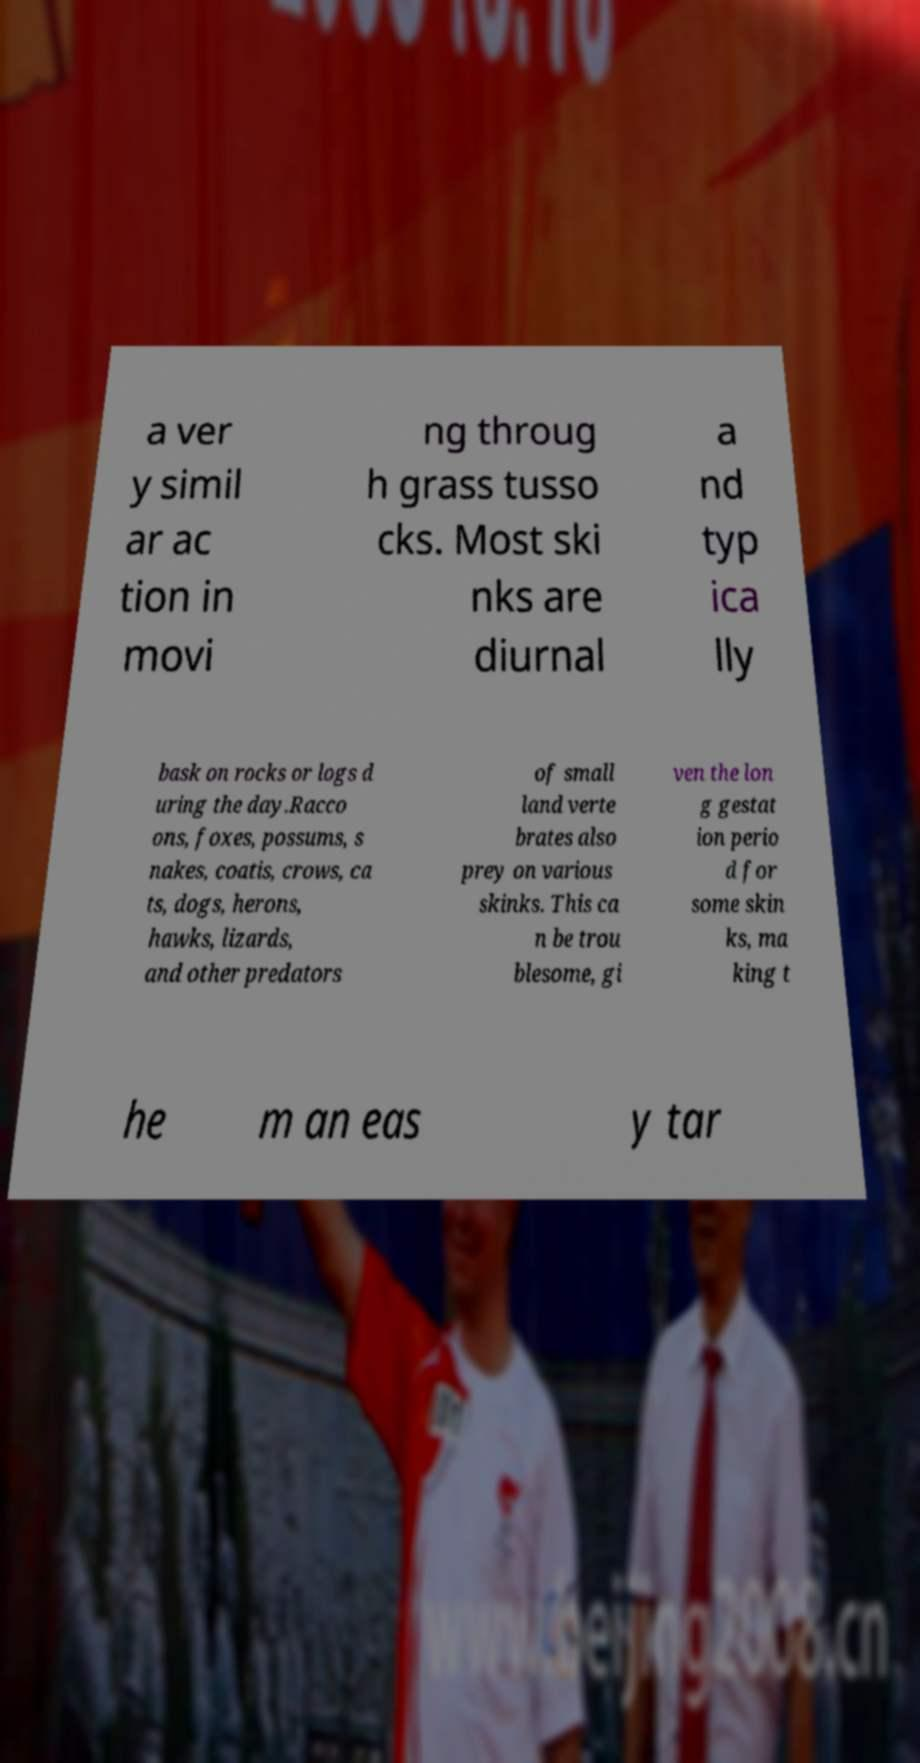What messages or text are displayed in this image? I need them in a readable, typed format. a ver y simil ar ac tion in movi ng throug h grass tusso cks. Most ski nks are diurnal a nd typ ica lly bask on rocks or logs d uring the day.Racco ons, foxes, possums, s nakes, coatis, crows, ca ts, dogs, herons, hawks, lizards, and other predators of small land verte brates also prey on various skinks. This ca n be trou blesome, gi ven the lon g gestat ion perio d for some skin ks, ma king t he m an eas y tar 